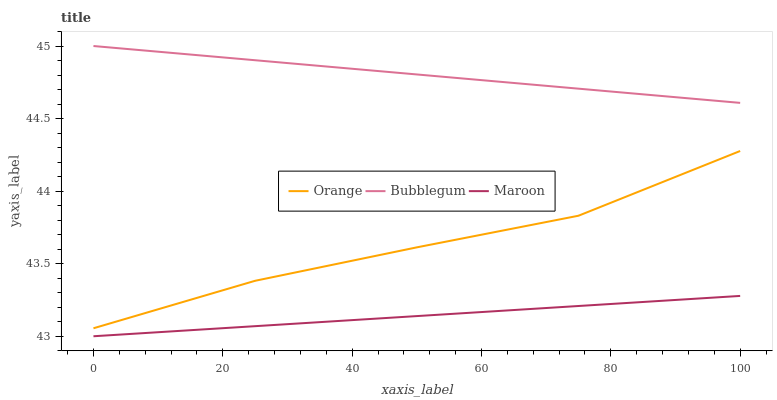Does Bubblegum have the minimum area under the curve?
Answer yes or no. No. Does Maroon have the maximum area under the curve?
Answer yes or no. No. Is Bubblegum the smoothest?
Answer yes or no. No. Is Bubblegum the roughest?
Answer yes or no. No. Does Bubblegum have the lowest value?
Answer yes or no. No. Does Maroon have the highest value?
Answer yes or no. No. Is Maroon less than Orange?
Answer yes or no. Yes. Is Bubblegum greater than Orange?
Answer yes or no. Yes. Does Maroon intersect Orange?
Answer yes or no. No. 